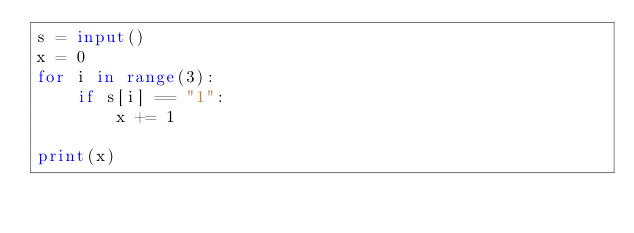Convert code to text. <code><loc_0><loc_0><loc_500><loc_500><_Python_>s = input()
x = 0
for i in range(3):
    if s[i] == "1":
        x += 1

print(x)</code> 